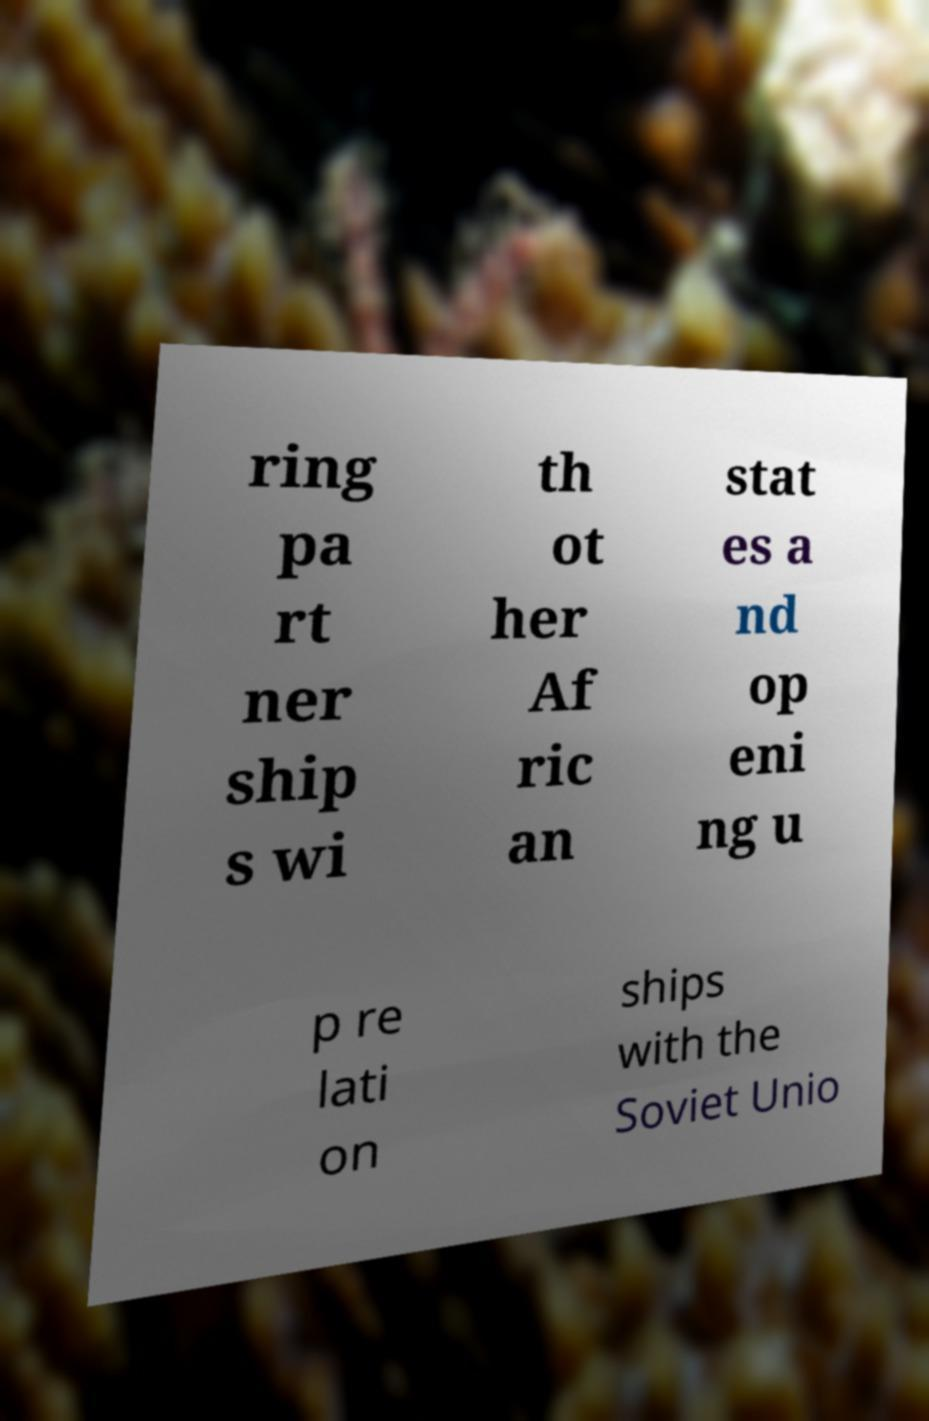Can you accurately transcribe the text from the provided image for me? ring pa rt ner ship s wi th ot her Af ric an stat es a nd op eni ng u p re lati on ships with the Soviet Unio 